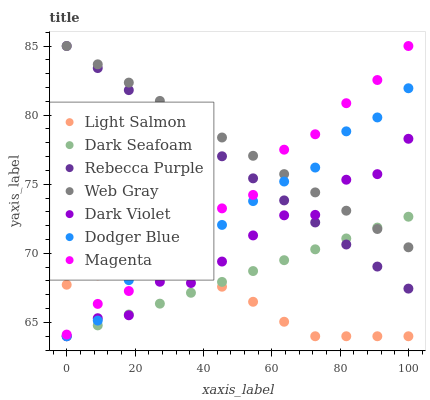Does Light Salmon have the minimum area under the curve?
Answer yes or no. Yes. Does Web Gray have the maximum area under the curve?
Answer yes or no. Yes. Does Dark Violet have the minimum area under the curve?
Answer yes or no. No. Does Dark Violet have the maximum area under the curve?
Answer yes or no. No. Is Rebecca Purple the smoothest?
Answer yes or no. Yes. Is Dark Violet the roughest?
Answer yes or no. Yes. Is Web Gray the smoothest?
Answer yes or no. No. Is Web Gray the roughest?
Answer yes or no. No. Does Light Salmon have the lowest value?
Answer yes or no. Yes. Does Web Gray have the lowest value?
Answer yes or no. No. Does Magenta have the highest value?
Answer yes or no. Yes. Does Dark Violet have the highest value?
Answer yes or no. No. Is Light Salmon less than Web Gray?
Answer yes or no. Yes. Is Web Gray greater than Light Salmon?
Answer yes or no. Yes. Does Web Gray intersect Magenta?
Answer yes or no. Yes. Is Web Gray less than Magenta?
Answer yes or no. No. Is Web Gray greater than Magenta?
Answer yes or no. No. Does Light Salmon intersect Web Gray?
Answer yes or no. No. 